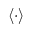<formula> <loc_0><loc_0><loc_500><loc_500>\, \left \langle { \cdot } \right \rangle</formula> 